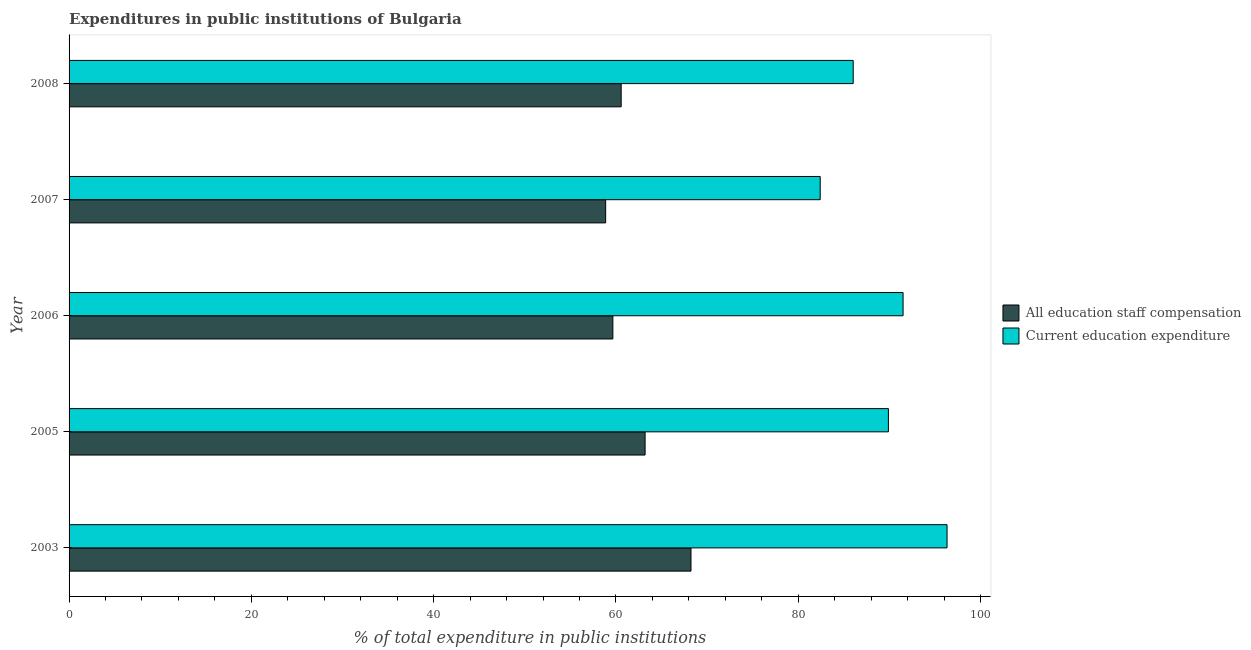How many bars are there on the 5th tick from the bottom?
Ensure brevity in your answer.  2. What is the label of the 5th group of bars from the top?
Your response must be concise. 2003. What is the expenditure in staff compensation in 2006?
Offer a very short reply. 59.66. Across all years, what is the maximum expenditure in education?
Offer a very short reply. 96.32. Across all years, what is the minimum expenditure in staff compensation?
Offer a very short reply. 58.87. In which year was the expenditure in staff compensation maximum?
Keep it short and to the point. 2003. In which year was the expenditure in staff compensation minimum?
Make the answer very short. 2007. What is the total expenditure in staff compensation in the graph?
Give a very brief answer. 310.53. What is the difference between the expenditure in staff compensation in 2003 and that in 2005?
Offer a terse response. 5.04. What is the difference between the expenditure in staff compensation in 2003 and the expenditure in education in 2007?
Offer a terse response. -14.18. What is the average expenditure in education per year?
Offer a very short reply. 89.23. In the year 2007, what is the difference between the expenditure in education and expenditure in staff compensation?
Give a very brief answer. 23.54. In how many years, is the expenditure in staff compensation greater than 16 %?
Give a very brief answer. 5. What is the ratio of the expenditure in staff compensation in 2003 to that in 2006?
Your answer should be compact. 1.14. Is the difference between the expenditure in education in 2005 and 2007 greater than the difference between the expenditure in staff compensation in 2005 and 2007?
Provide a short and direct response. Yes. What is the difference between the highest and the second highest expenditure in education?
Offer a terse response. 4.82. What is the difference between the highest and the lowest expenditure in education?
Give a very brief answer. 13.92. In how many years, is the expenditure in education greater than the average expenditure in education taken over all years?
Offer a terse response. 3. Is the sum of the expenditure in education in 2003 and 2008 greater than the maximum expenditure in staff compensation across all years?
Your response must be concise. Yes. What does the 2nd bar from the top in 2007 represents?
Provide a short and direct response. All education staff compensation. What does the 1st bar from the bottom in 2005 represents?
Your response must be concise. All education staff compensation. What is the difference between two consecutive major ticks on the X-axis?
Your response must be concise. 20. Does the graph contain any zero values?
Give a very brief answer. No. Does the graph contain grids?
Your response must be concise. No. What is the title of the graph?
Keep it short and to the point. Expenditures in public institutions of Bulgaria. Does "Private consumption" appear as one of the legend labels in the graph?
Give a very brief answer. No. What is the label or title of the X-axis?
Your response must be concise. % of total expenditure in public institutions. What is the label or title of the Y-axis?
Offer a terse response. Year. What is the % of total expenditure in public institutions of All education staff compensation in 2003?
Offer a very short reply. 68.23. What is the % of total expenditure in public institutions in Current education expenditure in 2003?
Your answer should be compact. 96.32. What is the % of total expenditure in public institutions of All education staff compensation in 2005?
Give a very brief answer. 63.2. What is the % of total expenditure in public institutions in Current education expenditure in 2005?
Provide a succinct answer. 89.89. What is the % of total expenditure in public institutions of All education staff compensation in 2006?
Provide a succinct answer. 59.66. What is the % of total expenditure in public institutions in Current education expenditure in 2006?
Offer a terse response. 91.5. What is the % of total expenditure in public institutions of All education staff compensation in 2007?
Your answer should be very brief. 58.87. What is the % of total expenditure in public institutions of Current education expenditure in 2007?
Your answer should be very brief. 82.41. What is the % of total expenditure in public institutions of All education staff compensation in 2008?
Provide a succinct answer. 60.57. What is the % of total expenditure in public institutions in Current education expenditure in 2008?
Your answer should be compact. 86.03. Across all years, what is the maximum % of total expenditure in public institutions in All education staff compensation?
Provide a succinct answer. 68.23. Across all years, what is the maximum % of total expenditure in public institutions of Current education expenditure?
Provide a short and direct response. 96.32. Across all years, what is the minimum % of total expenditure in public institutions of All education staff compensation?
Make the answer very short. 58.87. Across all years, what is the minimum % of total expenditure in public institutions in Current education expenditure?
Your response must be concise. 82.41. What is the total % of total expenditure in public institutions of All education staff compensation in the graph?
Your response must be concise. 310.53. What is the total % of total expenditure in public institutions of Current education expenditure in the graph?
Provide a succinct answer. 446.15. What is the difference between the % of total expenditure in public institutions of All education staff compensation in 2003 and that in 2005?
Offer a very short reply. 5.04. What is the difference between the % of total expenditure in public institutions in Current education expenditure in 2003 and that in 2005?
Offer a very short reply. 6.43. What is the difference between the % of total expenditure in public institutions in All education staff compensation in 2003 and that in 2006?
Your answer should be very brief. 8.57. What is the difference between the % of total expenditure in public institutions of Current education expenditure in 2003 and that in 2006?
Make the answer very short. 4.82. What is the difference between the % of total expenditure in public institutions of All education staff compensation in 2003 and that in 2007?
Your answer should be very brief. 9.36. What is the difference between the % of total expenditure in public institutions in Current education expenditure in 2003 and that in 2007?
Give a very brief answer. 13.92. What is the difference between the % of total expenditure in public institutions in All education staff compensation in 2003 and that in 2008?
Ensure brevity in your answer.  7.66. What is the difference between the % of total expenditure in public institutions of Current education expenditure in 2003 and that in 2008?
Ensure brevity in your answer.  10.3. What is the difference between the % of total expenditure in public institutions in All education staff compensation in 2005 and that in 2006?
Offer a very short reply. 3.54. What is the difference between the % of total expenditure in public institutions in Current education expenditure in 2005 and that in 2006?
Keep it short and to the point. -1.61. What is the difference between the % of total expenditure in public institutions of All education staff compensation in 2005 and that in 2007?
Offer a terse response. 4.33. What is the difference between the % of total expenditure in public institutions in Current education expenditure in 2005 and that in 2007?
Provide a short and direct response. 7.48. What is the difference between the % of total expenditure in public institutions in All education staff compensation in 2005 and that in 2008?
Provide a short and direct response. 2.62. What is the difference between the % of total expenditure in public institutions of Current education expenditure in 2005 and that in 2008?
Your answer should be very brief. 3.86. What is the difference between the % of total expenditure in public institutions of All education staff compensation in 2006 and that in 2007?
Offer a very short reply. 0.79. What is the difference between the % of total expenditure in public institutions in Current education expenditure in 2006 and that in 2007?
Provide a short and direct response. 9.09. What is the difference between the % of total expenditure in public institutions in All education staff compensation in 2006 and that in 2008?
Your answer should be compact. -0.91. What is the difference between the % of total expenditure in public institutions in Current education expenditure in 2006 and that in 2008?
Provide a succinct answer. 5.47. What is the difference between the % of total expenditure in public institutions in All education staff compensation in 2007 and that in 2008?
Provide a short and direct response. -1.7. What is the difference between the % of total expenditure in public institutions in Current education expenditure in 2007 and that in 2008?
Provide a short and direct response. -3.62. What is the difference between the % of total expenditure in public institutions of All education staff compensation in 2003 and the % of total expenditure in public institutions of Current education expenditure in 2005?
Ensure brevity in your answer.  -21.66. What is the difference between the % of total expenditure in public institutions of All education staff compensation in 2003 and the % of total expenditure in public institutions of Current education expenditure in 2006?
Provide a succinct answer. -23.27. What is the difference between the % of total expenditure in public institutions of All education staff compensation in 2003 and the % of total expenditure in public institutions of Current education expenditure in 2007?
Keep it short and to the point. -14.18. What is the difference between the % of total expenditure in public institutions of All education staff compensation in 2003 and the % of total expenditure in public institutions of Current education expenditure in 2008?
Offer a terse response. -17.8. What is the difference between the % of total expenditure in public institutions in All education staff compensation in 2005 and the % of total expenditure in public institutions in Current education expenditure in 2006?
Offer a terse response. -28.3. What is the difference between the % of total expenditure in public institutions of All education staff compensation in 2005 and the % of total expenditure in public institutions of Current education expenditure in 2007?
Give a very brief answer. -19.21. What is the difference between the % of total expenditure in public institutions in All education staff compensation in 2005 and the % of total expenditure in public institutions in Current education expenditure in 2008?
Give a very brief answer. -22.83. What is the difference between the % of total expenditure in public institutions of All education staff compensation in 2006 and the % of total expenditure in public institutions of Current education expenditure in 2007?
Offer a terse response. -22.75. What is the difference between the % of total expenditure in public institutions of All education staff compensation in 2006 and the % of total expenditure in public institutions of Current education expenditure in 2008?
Give a very brief answer. -26.37. What is the difference between the % of total expenditure in public institutions in All education staff compensation in 2007 and the % of total expenditure in public institutions in Current education expenditure in 2008?
Make the answer very short. -27.16. What is the average % of total expenditure in public institutions in All education staff compensation per year?
Give a very brief answer. 62.11. What is the average % of total expenditure in public institutions in Current education expenditure per year?
Provide a succinct answer. 89.23. In the year 2003, what is the difference between the % of total expenditure in public institutions in All education staff compensation and % of total expenditure in public institutions in Current education expenditure?
Offer a very short reply. -28.09. In the year 2005, what is the difference between the % of total expenditure in public institutions in All education staff compensation and % of total expenditure in public institutions in Current education expenditure?
Your answer should be very brief. -26.69. In the year 2006, what is the difference between the % of total expenditure in public institutions in All education staff compensation and % of total expenditure in public institutions in Current education expenditure?
Your answer should be very brief. -31.84. In the year 2007, what is the difference between the % of total expenditure in public institutions of All education staff compensation and % of total expenditure in public institutions of Current education expenditure?
Offer a very short reply. -23.54. In the year 2008, what is the difference between the % of total expenditure in public institutions of All education staff compensation and % of total expenditure in public institutions of Current education expenditure?
Offer a very short reply. -25.46. What is the ratio of the % of total expenditure in public institutions of All education staff compensation in 2003 to that in 2005?
Give a very brief answer. 1.08. What is the ratio of the % of total expenditure in public institutions in Current education expenditure in 2003 to that in 2005?
Provide a succinct answer. 1.07. What is the ratio of the % of total expenditure in public institutions of All education staff compensation in 2003 to that in 2006?
Your answer should be very brief. 1.14. What is the ratio of the % of total expenditure in public institutions in Current education expenditure in 2003 to that in 2006?
Offer a very short reply. 1.05. What is the ratio of the % of total expenditure in public institutions of All education staff compensation in 2003 to that in 2007?
Offer a terse response. 1.16. What is the ratio of the % of total expenditure in public institutions in Current education expenditure in 2003 to that in 2007?
Your answer should be compact. 1.17. What is the ratio of the % of total expenditure in public institutions of All education staff compensation in 2003 to that in 2008?
Your answer should be very brief. 1.13. What is the ratio of the % of total expenditure in public institutions of Current education expenditure in 2003 to that in 2008?
Make the answer very short. 1.12. What is the ratio of the % of total expenditure in public institutions in All education staff compensation in 2005 to that in 2006?
Make the answer very short. 1.06. What is the ratio of the % of total expenditure in public institutions in Current education expenditure in 2005 to that in 2006?
Your answer should be very brief. 0.98. What is the ratio of the % of total expenditure in public institutions in All education staff compensation in 2005 to that in 2007?
Your answer should be very brief. 1.07. What is the ratio of the % of total expenditure in public institutions in Current education expenditure in 2005 to that in 2007?
Offer a very short reply. 1.09. What is the ratio of the % of total expenditure in public institutions of All education staff compensation in 2005 to that in 2008?
Your response must be concise. 1.04. What is the ratio of the % of total expenditure in public institutions of Current education expenditure in 2005 to that in 2008?
Give a very brief answer. 1.04. What is the ratio of the % of total expenditure in public institutions of All education staff compensation in 2006 to that in 2007?
Your response must be concise. 1.01. What is the ratio of the % of total expenditure in public institutions in Current education expenditure in 2006 to that in 2007?
Your answer should be very brief. 1.11. What is the ratio of the % of total expenditure in public institutions of All education staff compensation in 2006 to that in 2008?
Give a very brief answer. 0.98. What is the ratio of the % of total expenditure in public institutions of Current education expenditure in 2006 to that in 2008?
Offer a terse response. 1.06. What is the ratio of the % of total expenditure in public institutions in All education staff compensation in 2007 to that in 2008?
Provide a succinct answer. 0.97. What is the ratio of the % of total expenditure in public institutions of Current education expenditure in 2007 to that in 2008?
Offer a terse response. 0.96. What is the difference between the highest and the second highest % of total expenditure in public institutions of All education staff compensation?
Your answer should be very brief. 5.04. What is the difference between the highest and the second highest % of total expenditure in public institutions of Current education expenditure?
Provide a short and direct response. 4.82. What is the difference between the highest and the lowest % of total expenditure in public institutions of All education staff compensation?
Your response must be concise. 9.36. What is the difference between the highest and the lowest % of total expenditure in public institutions of Current education expenditure?
Keep it short and to the point. 13.92. 